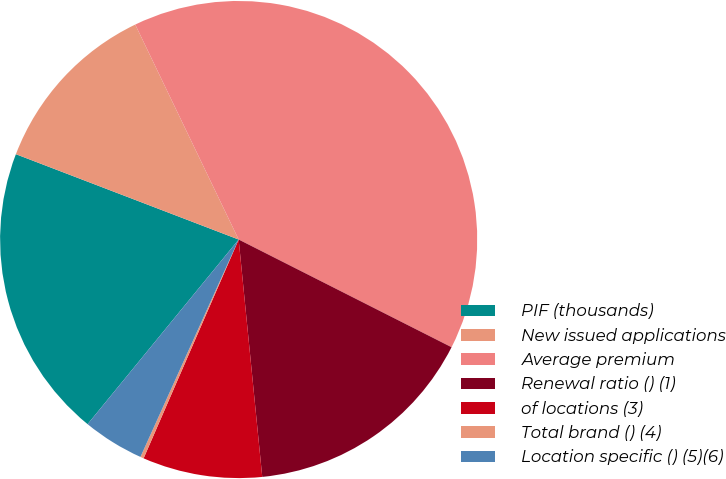Convert chart. <chart><loc_0><loc_0><loc_500><loc_500><pie_chart><fcel>PIF (thousands)<fcel>New issued applications<fcel>Average premium<fcel>Renewal ratio () (1)<fcel>of locations (3)<fcel>Total brand () (4)<fcel>Location specific () (5)(6)<nl><fcel>19.91%<fcel>12.04%<fcel>39.59%<fcel>15.97%<fcel>8.1%<fcel>0.23%<fcel>4.16%<nl></chart> 